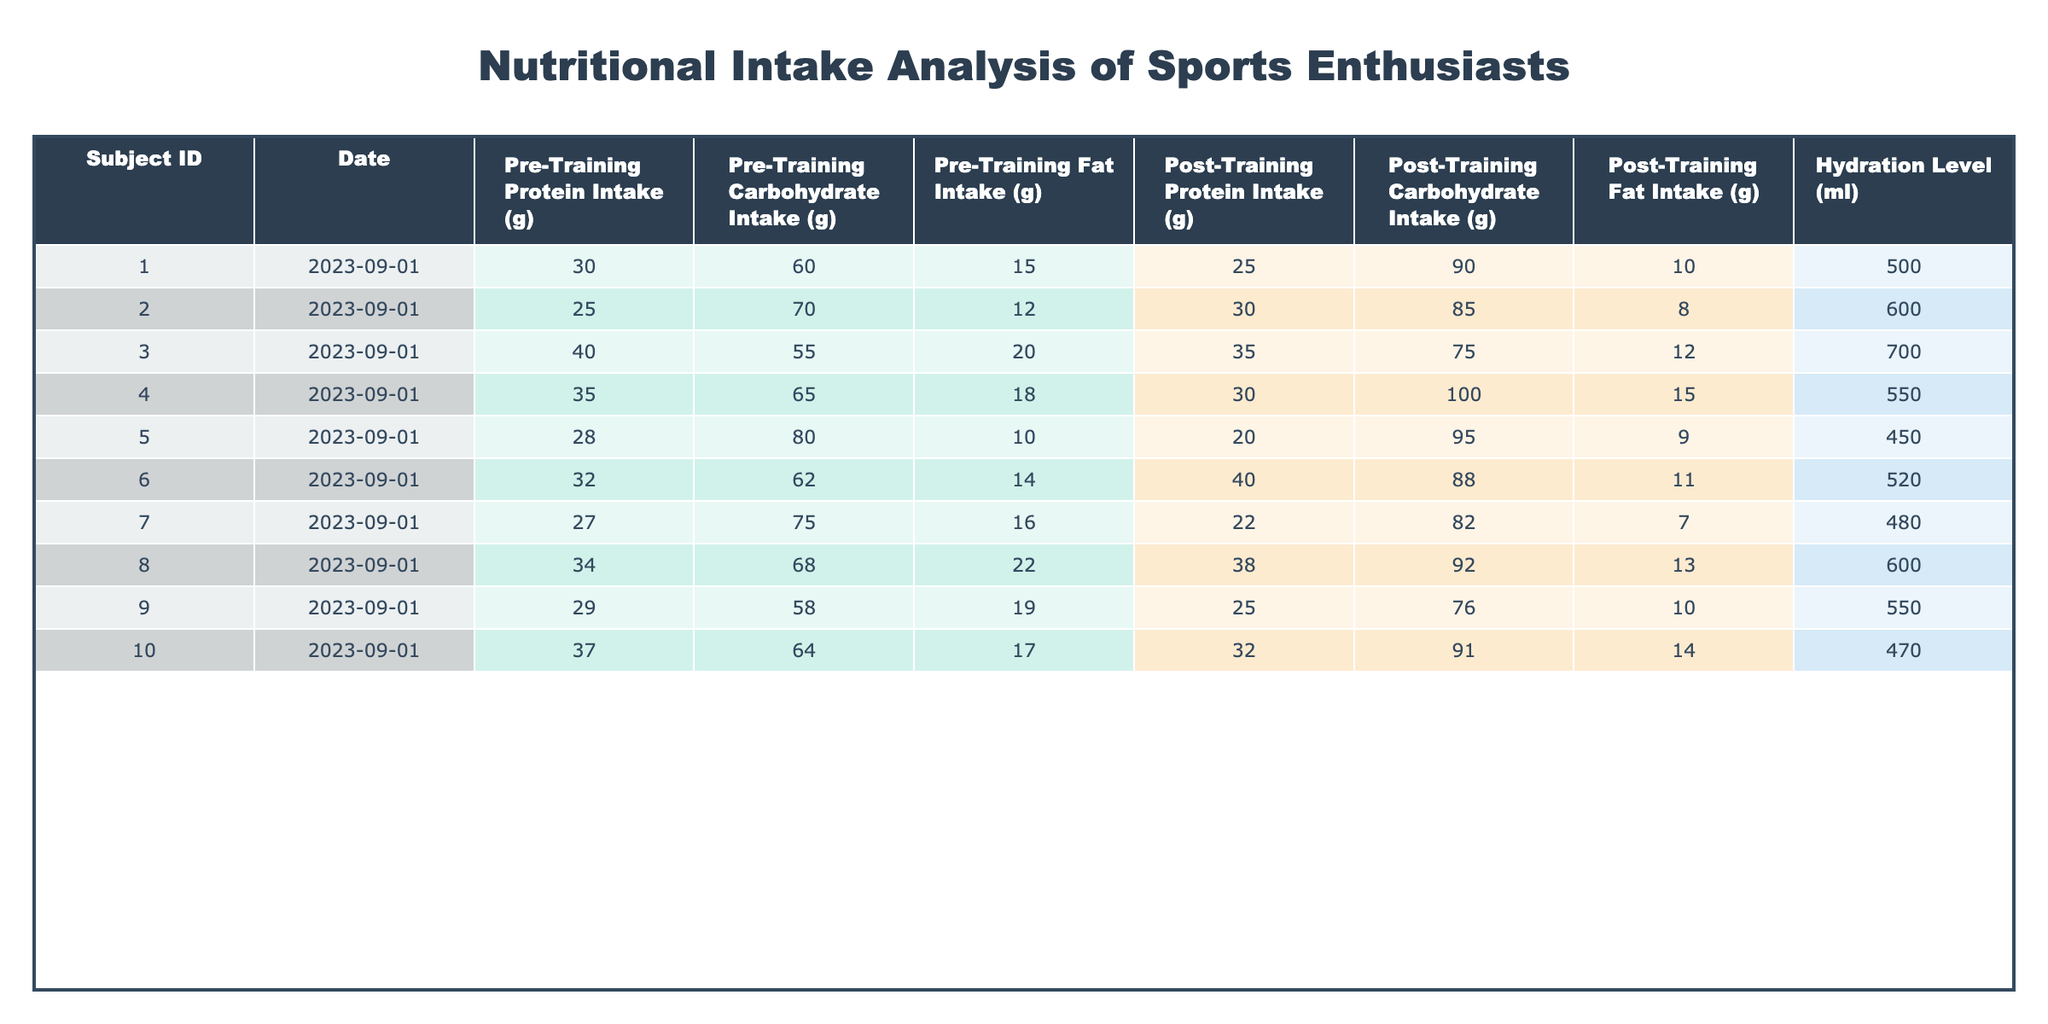What is the protein intake of Subject ID 003 after training? The table shows that the Post-Training Protein Intake for Subject ID 003 is 35 grams.
Answer: 35 grams What is the total carbohydrate intake for all subjects before training? To find the total carbohydrate intake before training, we sum the Pre-Training Carbohydrate Intake values: 60 + 70 + 55 + 65 + 80 + 62 + 75 + 68 + 58 + 64 =  648 grams.
Answer: 648 grams Did Subject ID 005 have a higher post-training carbohydrate intake than pre-training? Looking at Subject ID 005, the Pre-Training Carbohydrate Intake is 80 grams while the Post-Training Carbohydrate Intake is 95 grams, which means post-training was higher.
Answer: Yes What was the average fat intake before training for all subjects? To calculate the average fat intake before training, we add the Pre-Training Fat Intake values: 15 + 12 + 20 + 18 + 10 + 14 + 16 + 22 + 19 + 17 =  18.2 grams. There are 10 subjects, so the average is 182/10 = 18.2 grams.
Answer: 18.2 grams Which subject had the highest hydration level after training? Comparing the Hydration Level for all subjects after training, Subject ID 003 had the highest hydration level at 700 ml.
Answer: Subject ID 003 What is the difference in protein intake before and after training for Subject ID 004? For Subject ID 004, the Pre-Training Protein Intake is 35 grams and the Post-Training Protein Intake is 30 grams. The difference is 35 - 30 = 5 grams.
Answer: 5 grams Has the total fat intake increased for any subject after training? Analyzing each subject, we find that all subjects had lower fat intake post-training compared to pre-training. Thus, there was no increase in total fat intake for any subject.
Answer: No How many subjects had a hydration level greater than 550 ml after training? The hydration levels after training for each subject are: 500, 600, 700, 550, 450, 520, 480, 600, 550, and 470 ml. The subjects with hydration levels greater than 550 ml are Subjects ID 002, 003, 004, 008, and  Sou055, totaling 5 subjects.
Answer: 5 subjects 